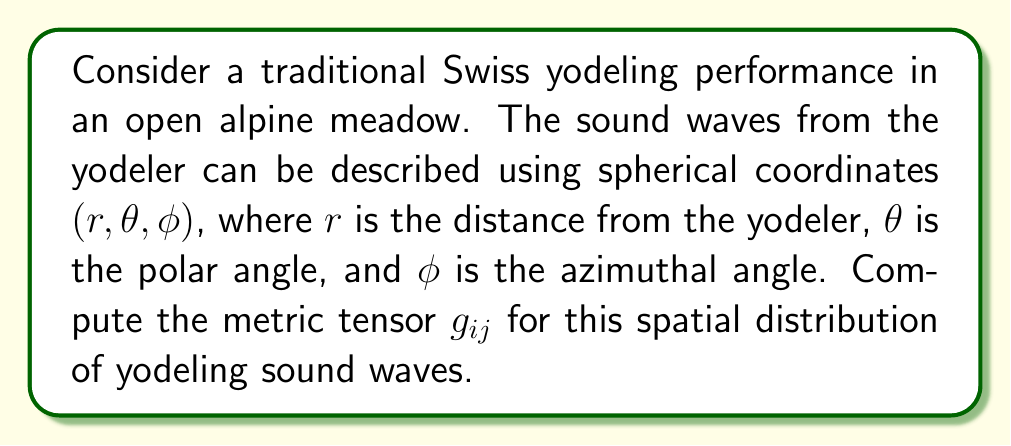Can you solve this math problem? To compute the metric tensor for the spatial distribution of yodeling sound waves, we'll follow these steps:

1) In spherical coordinates $(r, \theta, \phi)$, the line element is given by:

   $$ds^2 = dr^2 + r^2d\theta^2 + r^2\sin^2\theta d\phi^2$$

2) The metric tensor $g_{ij}$ is defined by the coefficients of the differentials in the line element:

   $$ds^2 = g_{ij}dx^idx^j$$

   where $x^1 = r$, $x^2 = \theta$, and $x^3 = \phi$

3) Comparing the two equations, we can identify the components of the metric tensor:

   $g_{11} = 1$ (coefficient of $dr^2$)
   $g_{22} = r^2$ (coefficient of $d\theta^2$)
   $g_{33} = r^2\sin^2\theta$ (coefficient of $d\phi^2$)

   All other components are zero because there are no cross terms.

4) Therefore, the metric tensor in matrix form is:

   $$g_{ij} = \begin{pmatrix}
   1 & 0 & 0 \\
   0 & r^2 & 0 \\
   0 & 0 & r^2\sin^2\theta
   \end{pmatrix}$$

This metric tensor describes how distances and angles are measured in the space around the yodeler, taking into account the spherical nature of sound wave propagation in the open alpine environment.
Answer: $$g_{ij} = \begin{pmatrix}
1 & 0 & 0 \\
0 & r^2 & 0 \\
0 & 0 & r^2\sin^2\theta
\end{pmatrix}$$ 